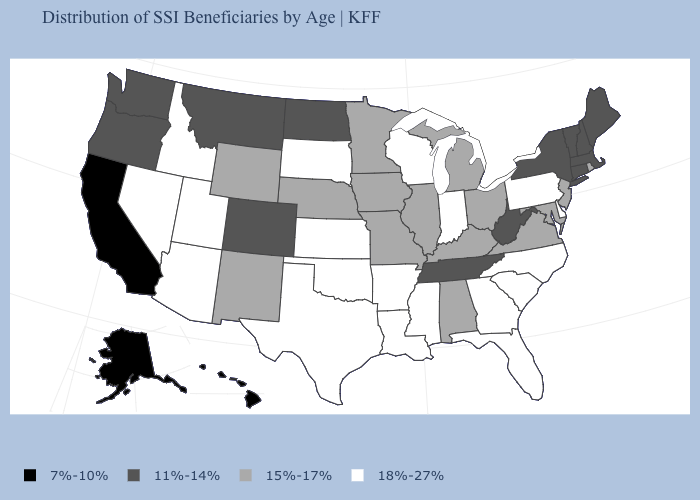Name the states that have a value in the range 11%-14%?
Concise answer only. Colorado, Connecticut, Maine, Massachusetts, Montana, New Hampshire, New York, North Dakota, Oregon, Tennessee, Vermont, Washington, West Virginia. Among the states that border North Carolina , does Virginia have the lowest value?
Be succinct. No. What is the value of Missouri?
Give a very brief answer. 15%-17%. Name the states that have a value in the range 15%-17%?
Answer briefly. Alabama, Illinois, Iowa, Kentucky, Maryland, Michigan, Minnesota, Missouri, Nebraska, New Jersey, New Mexico, Ohio, Rhode Island, Virginia, Wyoming. What is the value of Texas?
Be succinct. 18%-27%. What is the highest value in the USA?
Give a very brief answer. 18%-27%. Does Ohio have a higher value than Texas?
Quick response, please. No. Does Hawaii have the highest value in the USA?
Be succinct. No. What is the value of West Virginia?
Give a very brief answer. 11%-14%. What is the value of Hawaii?
Write a very short answer. 7%-10%. Does New Hampshire have the highest value in the USA?
Quick response, please. No. Name the states that have a value in the range 11%-14%?
Keep it brief. Colorado, Connecticut, Maine, Massachusetts, Montana, New Hampshire, New York, North Dakota, Oregon, Tennessee, Vermont, Washington, West Virginia. How many symbols are there in the legend?
Give a very brief answer. 4. Name the states that have a value in the range 18%-27%?
Give a very brief answer. Arizona, Arkansas, Delaware, Florida, Georgia, Idaho, Indiana, Kansas, Louisiana, Mississippi, Nevada, North Carolina, Oklahoma, Pennsylvania, South Carolina, South Dakota, Texas, Utah, Wisconsin. What is the value of Montana?
Give a very brief answer. 11%-14%. 